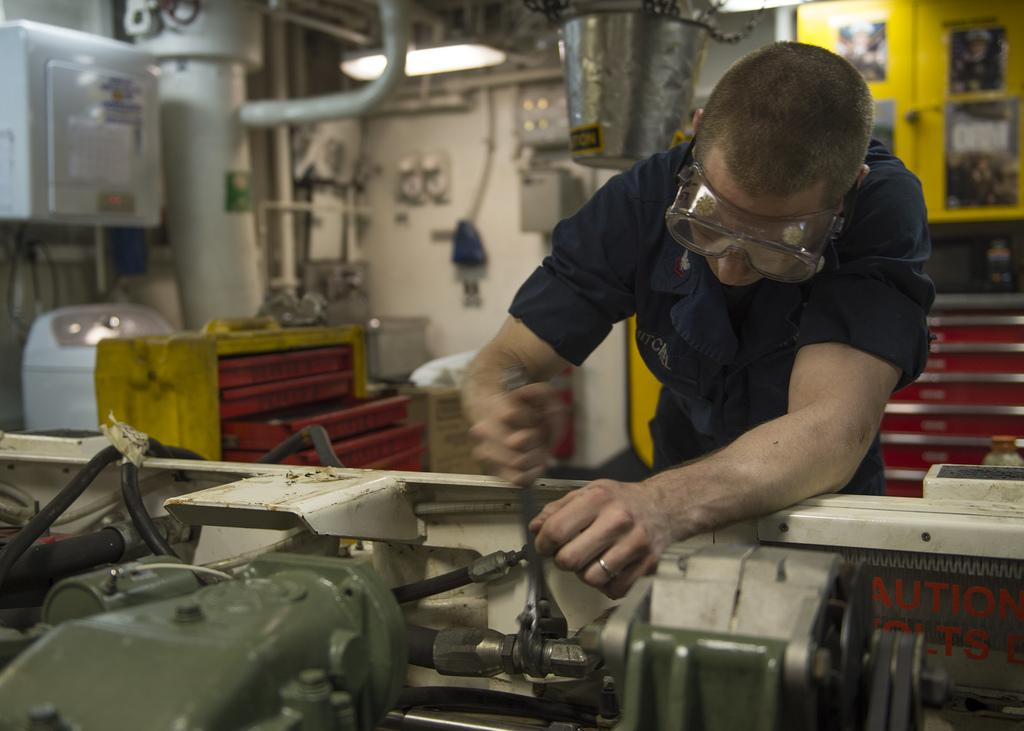What is the main subject of the image? There is a person in the image. What is the person doing in the image? The person is standing and repairing a machine. What can be seen in the background of the image? There is a light, a cupboard, and other machines in the background of the image. Can you tell me how many monkeys are sitting on the cupboard in the image? There are no monkeys present in the image; it features a person repairing a machine and various background elements. What type of cat can be seen playing with the machine in the image? There is no cat present in the image; it only shows a person repairing a machine and the surrounding environment. 